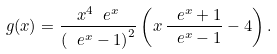<formula> <loc_0><loc_0><loc_500><loc_500>g ( x ) = \frac { x ^ { 4 } \ e ^ { x } } { \left ( \ e ^ { x } - 1 \right ) ^ { 2 } } \left ( x \, \frac { \ e ^ { x } + 1 } { \ e ^ { x } - 1 } - 4 \right ) .</formula> 